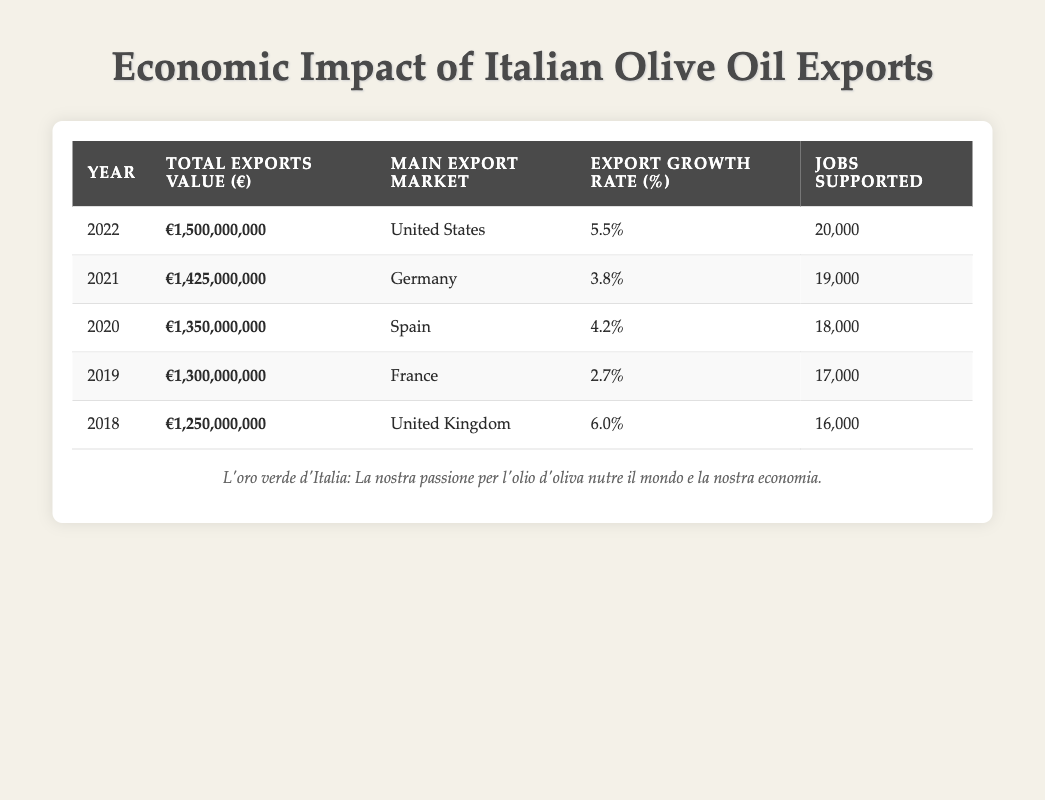What was the total export value of olive oil from Italy in 2021? The table shows that in 2021, the "Total Exports Value" is listed as €1,425,000,000.
Answer: €1,425,000,000 Which market was the main export destination for olive oil in 2020? According to the table, the "Main Export Market" for 2020 is "Spain."
Answer: Spain What was the export growth rate percentage for olive oil in 2019? The table indicates that the "Export Growth Rate" for the year 2019 is 2.7%.
Answer: 2.7% How many jobs were supported by olive oil exports in 2022? From the table, it is clear that the number of "Jobs Supported" in 2022 is 20,000.
Answer: 20,000 What is the average total exports value for the years 2019 to 2021? To find the average, first sum the total exports values for the years 2019 (€1,300,000,000), 2020 (€1,350,000,000), and 2021 (€1,425,000,000): €1,300,000,000 + €1,350,000,000 + €1,425,000,000 = €4,075,000,000. There are 3 years, so the average is €4,075,000,000 / 3 = €1,358,333,333.33.
Answer: €1,358,333,333.33 What is the difference in jobs supported between 2022 and 2018? In the table, jobs supported in 2022 is 20,000 and in 2018 is 16,000. The difference is 20,000 - 16,000 = 4,000.
Answer: 4,000 Was there an increase or decrease in the export growth rate from 2020 to 2021? The export growth rate in 2020 is 4.2% and in 2021 is 3.8%. Since 4.2% is greater than 3.8%, it shows a decrease in the growth rate from 2020 to 2021.
Answer: Decrease Which year saw the highest export growth rate, and what was it? Reviewing the table, the highest export growth rate is in 2018 at 6.0%.
Answer: 2018, 6.0% What can be said about the relationship between export growth rates and jobs supported from 2019 to 2022? By looking at the data, the export growth rates have generally increased along with the number of jobs supported. However, the growth rate decreased from 2020 to 2021 while jobs increased. This shows that the two metrics do not have a direct correlation in every instance.
Answer: There is no consistent relationship 